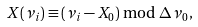Convert formula to latex. <formula><loc_0><loc_0><loc_500><loc_500>X ( \nu _ { i } ) \equiv ( \nu _ { i } - X _ { 0 } ) \bmod \Delta \nu _ { 0 } \, ,</formula> 